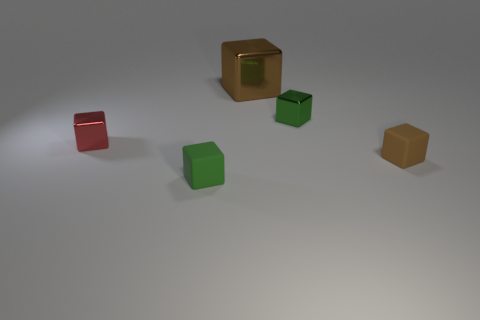There is a green object that is made of the same material as the red block; what size is it?
Your response must be concise. Small. Are there any other small rubber things that have the same shape as the red thing?
Provide a short and direct response. Yes. How many objects are small rubber objects behind the green matte object or small green matte cubes?
Your answer should be compact. 2. There is a block that is the same color as the large thing; what size is it?
Offer a very short reply. Small. There is a metallic thing that is right of the large cube; does it have the same color as the matte thing that is on the right side of the big shiny cube?
Offer a very short reply. No. What size is the green metal thing?
Keep it short and to the point. Small. How many big things are brown matte blocks or brown shiny cubes?
Ensure brevity in your answer.  1. There is another shiny object that is the same size as the red metal object; what color is it?
Provide a short and direct response. Green. What number of other objects are there of the same shape as the green rubber object?
Provide a short and direct response. 4. Are there any large cylinders made of the same material as the small brown object?
Your answer should be very brief. No. 